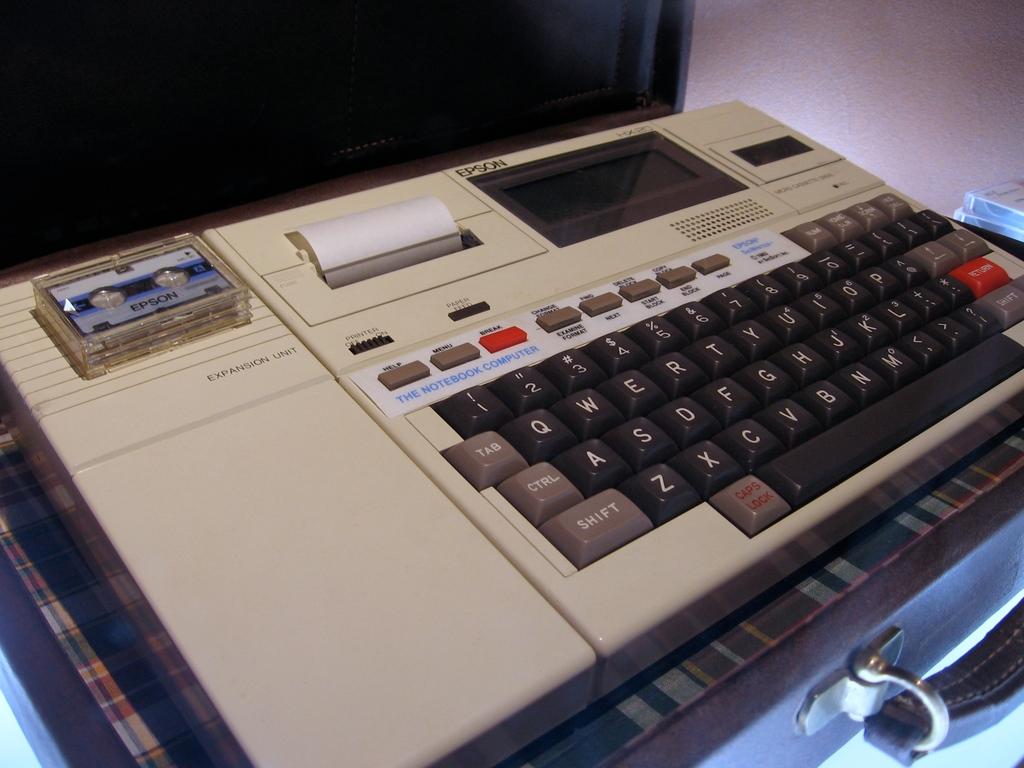Does this keyboard have a ctrl button?
Your response must be concise. Yes. Does the keyboard have a q button?
Your answer should be very brief. Yes. 